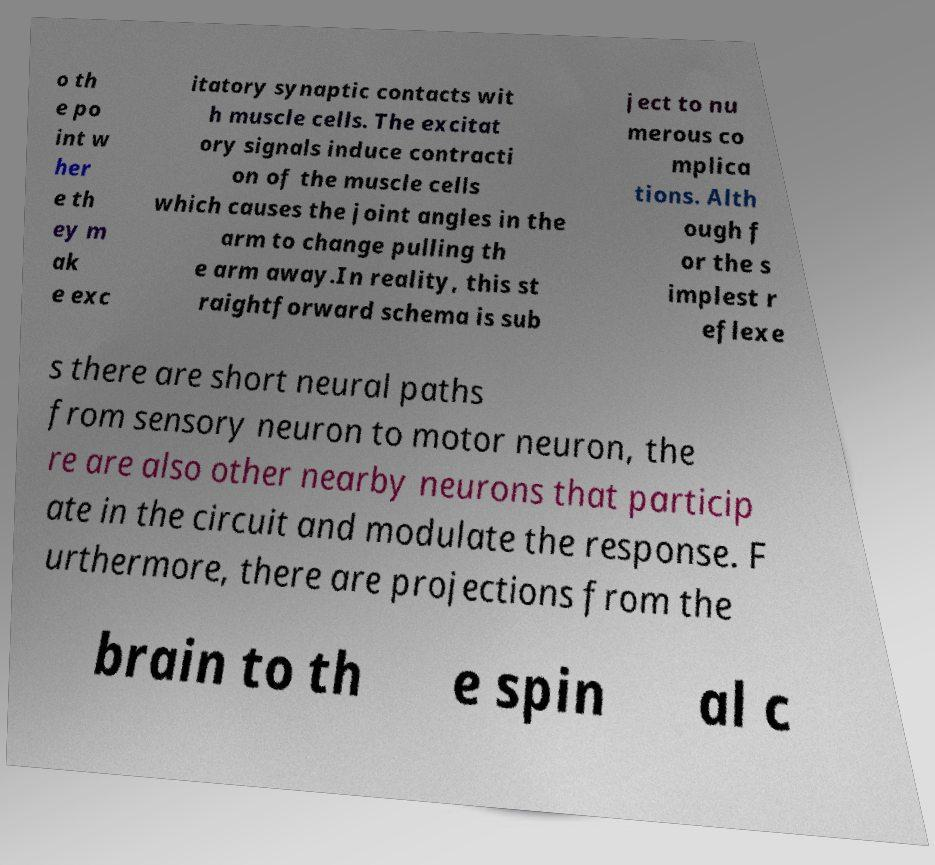What messages or text are displayed in this image? I need them in a readable, typed format. o th e po int w her e th ey m ak e exc itatory synaptic contacts wit h muscle cells. The excitat ory signals induce contracti on of the muscle cells which causes the joint angles in the arm to change pulling th e arm away.In reality, this st raightforward schema is sub ject to nu merous co mplica tions. Alth ough f or the s implest r eflexe s there are short neural paths from sensory neuron to motor neuron, the re are also other nearby neurons that particip ate in the circuit and modulate the response. F urthermore, there are projections from the brain to th e spin al c 